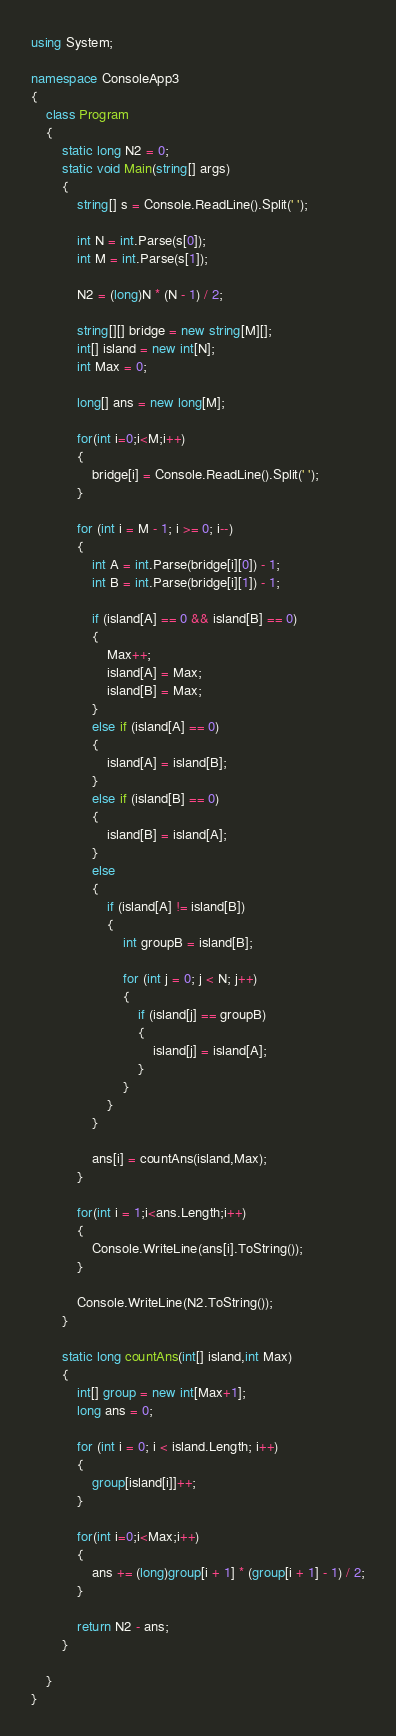<code> <loc_0><loc_0><loc_500><loc_500><_C#_>using System;

namespace ConsoleApp3
{
    class Program
    {
        static long N2 = 0;
        static void Main(string[] args)
        {
            string[] s = Console.ReadLine().Split(' ');

            int N = int.Parse(s[0]);
            int M = int.Parse(s[1]);

            N2 = (long)N * (N - 1) / 2;

            string[][] bridge = new string[M][];
            int[] island = new int[N];
            int Max = 0;

            long[] ans = new long[M];

            for(int i=0;i<M;i++)
            {
                bridge[i] = Console.ReadLine().Split(' ');
            }

            for (int i = M - 1; i >= 0; i--)
            {
                int A = int.Parse(bridge[i][0]) - 1;
                int B = int.Parse(bridge[i][1]) - 1;

                if (island[A] == 0 && island[B] == 0)
                {
                    Max++;
                    island[A] = Max;
                    island[B] = Max;
                }
                else if (island[A] == 0)
                {
                    island[A] = island[B];
                }
                else if (island[B] == 0)
                {
                    island[B] = island[A];
                }
                else
                {
                    if (island[A] != island[B])
                    {
                        int groupB = island[B];

                        for (int j = 0; j < N; j++)
                        {
                            if (island[j] == groupB)
                            {
                                island[j] = island[A];
                            }
                        }
                    }
                }

                ans[i] = countAns(island,Max);
            }

            for(int i = 1;i<ans.Length;i++)
            {
                Console.WriteLine(ans[i].ToString());
            }

            Console.WriteLine(N2.ToString());
        }

        static long countAns(int[] island,int Max)
        {
            int[] group = new int[Max+1];
            long ans = 0;

            for (int i = 0; i < island.Length; i++)
            {
                group[island[i]]++;
            }

            for(int i=0;i<Max;i++)
            {
                ans += (long)group[i + 1] * (group[i + 1] - 1) / 2;
            }

            return N2 - ans;
        }

    }
}
</code> 